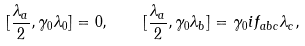<formula> <loc_0><loc_0><loc_500><loc_500>[ \frac { \lambda _ { a } } { 2 } , \gamma _ { 0 } \lambda _ { 0 } ] = 0 , \quad [ \frac { \lambda _ { a } } { 2 } , \gamma _ { 0 } \lambda _ { b } ] = \gamma _ { 0 } i f _ { a b c } \lambda _ { c } ,</formula> 